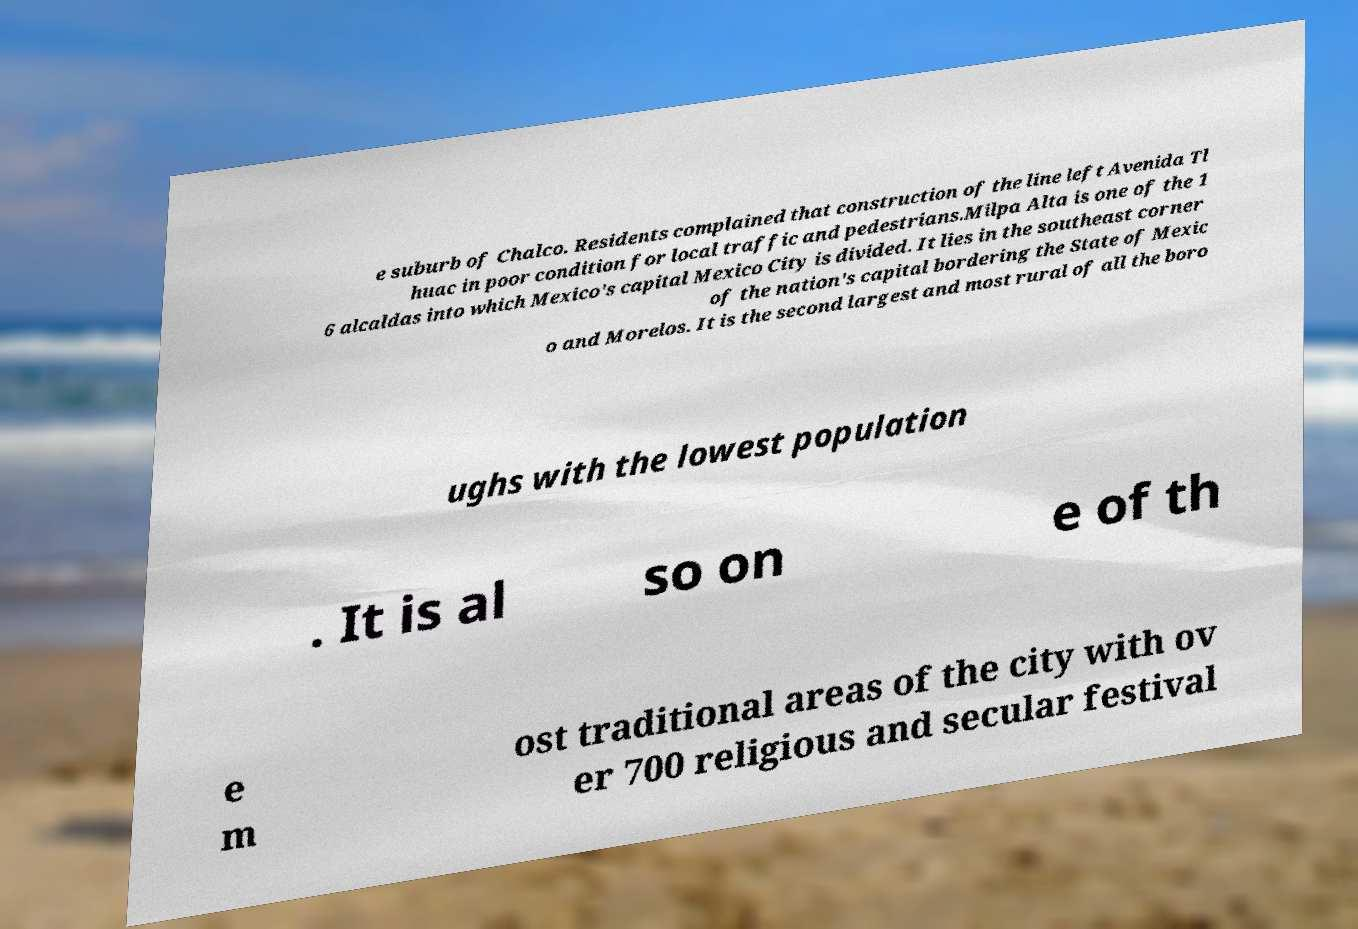There's text embedded in this image that I need extracted. Can you transcribe it verbatim? e suburb of Chalco. Residents complained that construction of the line left Avenida Tl huac in poor condition for local traffic and pedestrians.Milpa Alta is one of the 1 6 alcaldas into which Mexico's capital Mexico City is divided. It lies in the southeast corner of the nation's capital bordering the State of Mexic o and Morelos. It is the second largest and most rural of all the boro ughs with the lowest population . It is al so on e of th e m ost traditional areas of the city with ov er 700 religious and secular festival 